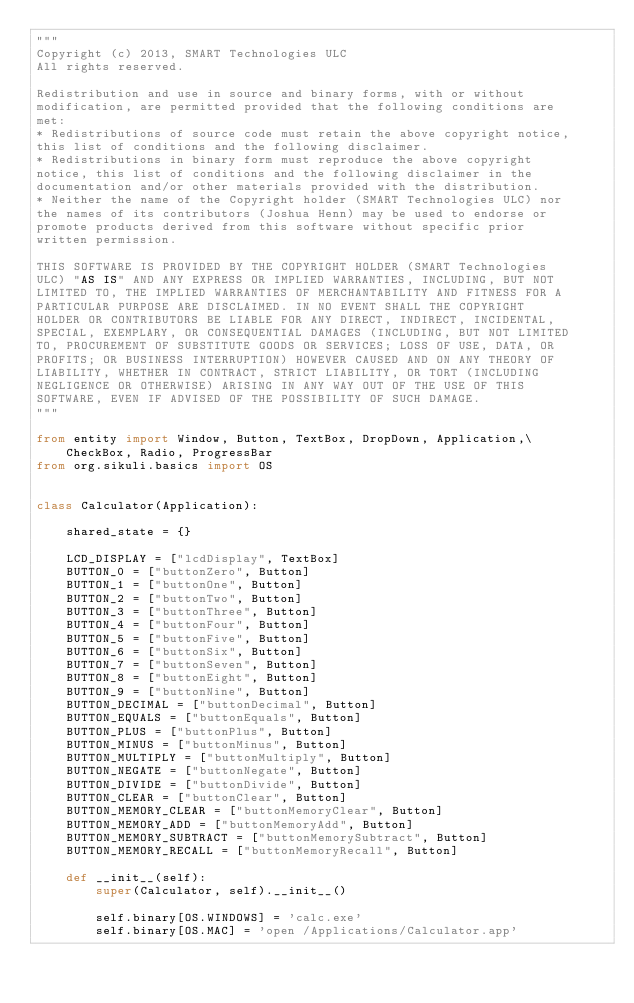Convert code to text. <code><loc_0><loc_0><loc_500><loc_500><_Python_>"""
Copyright (c) 2013, SMART Technologies ULC 
All rights reserved.

Redistribution and use in source and binary forms, with or without
modification, are permitted provided that the following conditions are
met:
* Redistributions of source code must retain the above copyright notice,
this list of conditions and the following disclaimer.
* Redistributions in binary form must reproduce the above copyright
notice, this list of conditions and the following disclaimer in the
documentation and/or other materials provided with the distribution.
* Neither the name of the Copyright holder (SMART Technologies ULC) nor
the names of its contributors (Joshua Henn) may be used to endorse or
promote products derived from this software without specific prior
written permission.

THIS SOFTWARE IS PROVIDED BY THE COPYRIGHT HOLDER (SMART Technologies
ULC) "AS IS" AND ANY EXPRESS OR IMPLIED WARRANTIES, INCLUDING, BUT NOT
LIMITED TO, THE IMPLIED WARRANTIES OF MERCHANTABILITY AND FITNESS FOR A
PARTICULAR PURPOSE ARE DISCLAIMED. IN NO EVENT SHALL THE COPYRIGHT
HOLDER OR CONTRIBUTORS BE LIABLE FOR ANY DIRECT, INDIRECT, INCIDENTAL,
SPECIAL, EXEMPLARY, OR CONSEQUENTIAL DAMAGES (INCLUDING, BUT NOT LIMITED
TO, PROCUREMENT OF SUBSTITUTE GOODS OR SERVICES; LOSS OF USE, DATA, OR
PROFITS; OR BUSINESS INTERRUPTION) HOWEVER CAUSED AND ON ANY THEORY OF
LIABILITY, WHETHER IN CONTRACT, STRICT LIABILITY, OR TORT (INCLUDING
NEGLIGENCE OR OTHERWISE) ARISING IN ANY WAY OUT OF THE USE OF THIS
SOFTWARE, EVEN IF ADVISED OF THE POSSIBILITY OF SUCH DAMAGE.
"""

from entity import Window, Button, TextBox, DropDown, Application,\
    CheckBox, Radio, ProgressBar
from org.sikuli.basics import OS

        
class Calculator(Application):
    
    shared_state = {}

    LCD_DISPLAY = ["lcdDisplay", TextBox]
    BUTTON_0 = ["buttonZero", Button]
    BUTTON_1 = ["buttonOne", Button]
    BUTTON_2 = ["buttonTwo", Button]
    BUTTON_3 = ["buttonThree", Button]
    BUTTON_4 = ["buttonFour", Button]
    BUTTON_5 = ["buttonFive", Button]
    BUTTON_6 = ["buttonSix", Button]
    BUTTON_7 = ["buttonSeven", Button]
    BUTTON_8 = ["buttonEight", Button]
    BUTTON_9 = ["buttonNine", Button]
    BUTTON_DECIMAL = ["buttonDecimal", Button]
    BUTTON_EQUALS = ["buttonEquals", Button]
    BUTTON_PLUS = ["buttonPlus", Button]
    BUTTON_MINUS = ["buttonMinus", Button]
    BUTTON_MULTIPLY = ["buttonMultiply", Button]
    BUTTON_NEGATE = ["buttonNegate", Button]
    BUTTON_DIVIDE = ["buttonDivide", Button]
    BUTTON_CLEAR = ["buttonClear", Button]
    BUTTON_MEMORY_CLEAR = ["buttonMemoryClear", Button]
    BUTTON_MEMORY_ADD = ["buttonMemoryAdd", Button]
    BUTTON_MEMORY_SUBTRACT = ["buttonMemorySubtract", Button]
    BUTTON_MEMORY_RECALL = ["buttonMemoryRecall", Button]

    def __init__(self):
        super(Calculator, self).__init__()

        self.binary[OS.WINDOWS] = 'calc.exe'
        self.binary[OS.MAC] = 'open /Applications/Calculator.app'
    </code> 